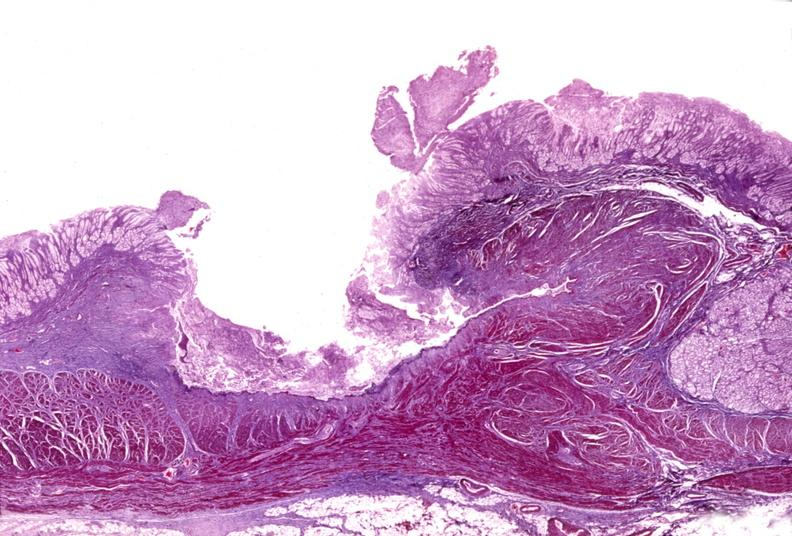where is this from?
Answer the question using a single word or phrase. Gastrointestinal system 